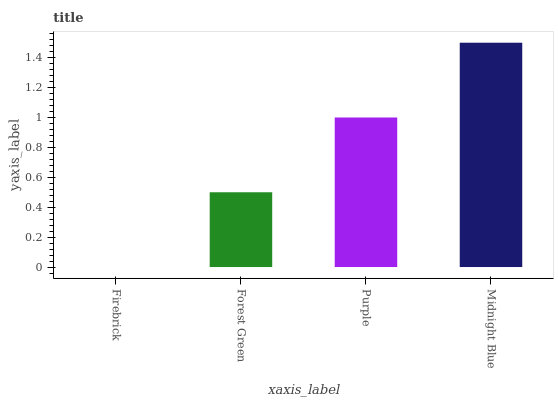Is Firebrick the minimum?
Answer yes or no. Yes. Is Midnight Blue the maximum?
Answer yes or no. Yes. Is Forest Green the minimum?
Answer yes or no. No. Is Forest Green the maximum?
Answer yes or no. No. Is Forest Green greater than Firebrick?
Answer yes or no. Yes. Is Firebrick less than Forest Green?
Answer yes or no. Yes. Is Firebrick greater than Forest Green?
Answer yes or no. No. Is Forest Green less than Firebrick?
Answer yes or no. No. Is Purple the high median?
Answer yes or no. Yes. Is Forest Green the low median?
Answer yes or no. Yes. Is Forest Green the high median?
Answer yes or no. No. Is Purple the low median?
Answer yes or no. No. 